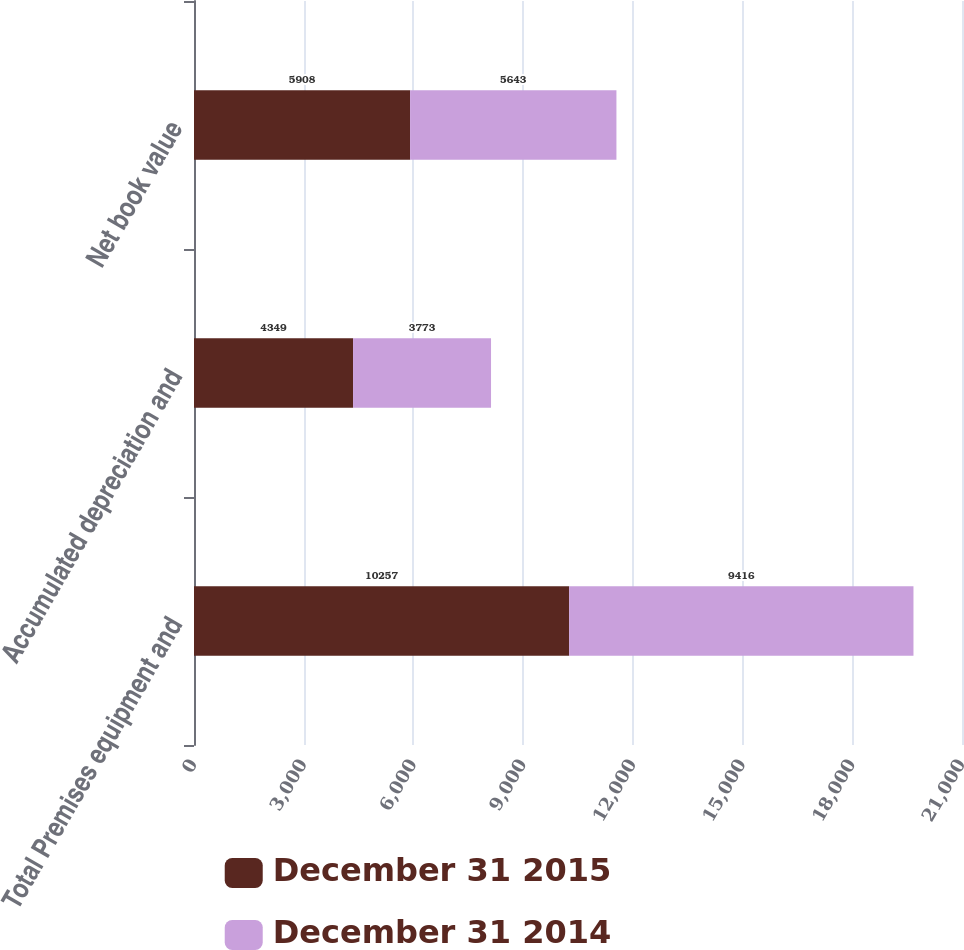Convert chart to OTSL. <chart><loc_0><loc_0><loc_500><loc_500><stacked_bar_chart><ecel><fcel>Total Premises equipment and<fcel>Accumulated depreciation and<fcel>Net book value<nl><fcel>December 31 2015<fcel>10257<fcel>4349<fcel>5908<nl><fcel>December 31 2014<fcel>9416<fcel>3773<fcel>5643<nl></chart> 